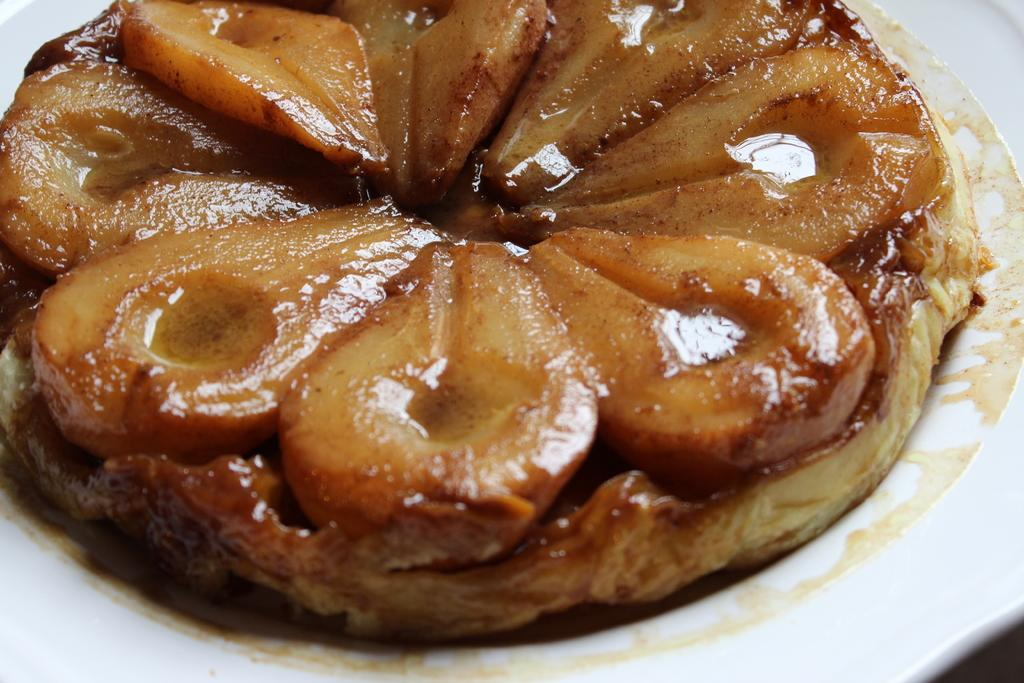What is the main subject of the image? There is a food item in the image. How is the food item presented in the image? The food item is placed on a white color plate. How many books can be seen on the plate with the food item in the image? There are no books present in the image; it only features a food item on a white color plate. Is there a person wearing a mitten holding the plate in the image? There is no person or mitten visible in the image; it only shows a food item on a white color plate. 